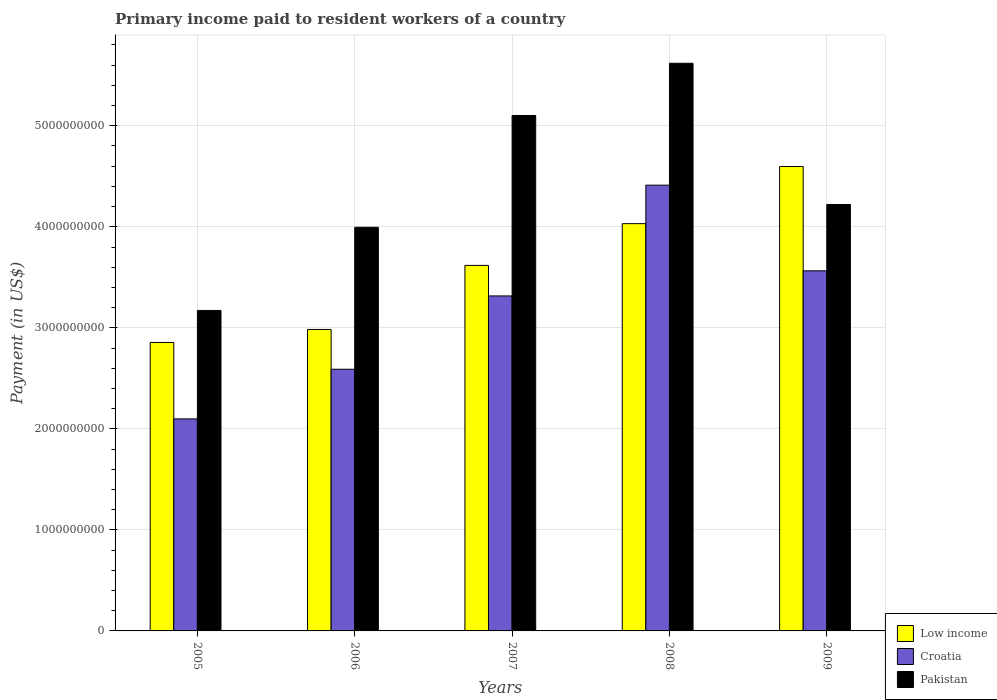How many different coloured bars are there?
Offer a terse response. 3. How many groups of bars are there?
Your response must be concise. 5. Are the number of bars on each tick of the X-axis equal?
Offer a very short reply. Yes. How many bars are there on the 5th tick from the right?
Provide a short and direct response. 3. What is the label of the 5th group of bars from the left?
Give a very brief answer. 2009. In how many cases, is the number of bars for a given year not equal to the number of legend labels?
Your answer should be compact. 0. What is the amount paid to workers in Pakistan in 2009?
Provide a succinct answer. 4.22e+09. Across all years, what is the maximum amount paid to workers in Low income?
Offer a very short reply. 4.60e+09. Across all years, what is the minimum amount paid to workers in Croatia?
Give a very brief answer. 2.10e+09. In which year was the amount paid to workers in Pakistan maximum?
Offer a very short reply. 2008. What is the total amount paid to workers in Pakistan in the graph?
Keep it short and to the point. 2.21e+1. What is the difference between the amount paid to workers in Croatia in 2006 and that in 2008?
Make the answer very short. -1.82e+09. What is the difference between the amount paid to workers in Low income in 2008 and the amount paid to workers in Croatia in 2007?
Keep it short and to the point. 7.16e+08. What is the average amount paid to workers in Croatia per year?
Your answer should be compact. 3.20e+09. In the year 2009, what is the difference between the amount paid to workers in Croatia and amount paid to workers in Pakistan?
Ensure brevity in your answer.  -6.57e+08. In how many years, is the amount paid to workers in Croatia greater than 3000000000 US$?
Ensure brevity in your answer.  3. What is the ratio of the amount paid to workers in Low income in 2005 to that in 2006?
Provide a short and direct response. 0.96. What is the difference between the highest and the second highest amount paid to workers in Pakistan?
Make the answer very short. 5.17e+08. What is the difference between the highest and the lowest amount paid to workers in Pakistan?
Your answer should be very brief. 2.45e+09. In how many years, is the amount paid to workers in Low income greater than the average amount paid to workers in Low income taken over all years?
Ensure brevity in your answer.  3. Is the sum of the amount paid to workers in Pakistan in 2006 and 2009 greater than the maximum amount paid to workers in Low income across all years?
Offer a terse response. Yes. What does the 2nd bar from the right in 2006 represents?
Provide a succinct answer. Croatia. How many years are there in the graph?
Your response must be concise. 5. Are the values on the major ticks of Y-axis written in scientific E-notation?
Give a very brief answer. No. Does the graph contain any zero values?
Your response must be concise. No. Does the graph contain grids?
Keep it short and to the point. Yes. How many legend labels are there?
Provide a succinct answer. 3. What is the title of the graph?
Ensure brevity in your answer.  Primary income paid to resident workers of a country. Does "Guam" appear as one of the legend labels in the graph?
Provide a short and direct response. No. What is the label or title of the X-axis?
Ensure brevity in your answer.  Years. What is the label or title of the Y-axis?
Offer a terse response. Payment (in US$). What is the Payment (in US$) of Low income in 2005?
Your response must be concise. 2.86e+09. What is the Payment (in US$) in Croatia in 2005?
Provide a succinct answer. 2.10e+09. What is the Payment (in US$) of Pakistan in 2005?
Your answer should be compact. 3.17e+09. What is the Payment (in US$) of Low income in 2006?
Offer a terse response. 2.98e+09. What is the Payment (in US$) in Croatia in 2006?
Your answer should be very brief. 2.59e+09. What is the Payment (in US$) in Pakistan in 2006?
Your answer should be very brief. 4.00e+09. What is the Payment (in US$) of Low income in 2007?
Ensure brevity in your answer.  3.62e+09. What is the Payment (in US$) of Croatia in 2007?
Your response must be concise. 3.32e+09. What is the Payment (in US$) of Pakistan in 2007?
Offer a very short reply. 5.10e+09. What is the Payment (in US$) in Low income in 2008?
Your answer should be compact. 4.03e+09. What is the Payment (in US$) in Croatia in 2008?
Provide a short and direct response. 4.41e+09. What is the Payment (in US$) of Pakistan in 2008?
Keep it short and to the point. 5.62e+09. What is the Payment (in US$) of Low income in 2009?
Your answer should be very brief. 4.60e+09. What is the Payment (in US$) in Croatia in 2009?
Provide a short and direct response. 3.56e+09. What is the Payment (in US$) of Pakistan in 2009?
Ensure brevity in your answer.  4.22e+09. Across all years, what is the maximum Payment (in US$) of Low income?
Keep it short and to the point. 4.60e+09. Across all years, what is the maximum Payment (in US$) of Croatia?
Offer a terse response. 4.41e+09. Across all years, what is the maximum Payment (in US$) of Pakistan?
Provide a short and direct response. 5.62e+09. Across all years, what is the minimum Payment (in US$) of Low income?
Provide a succinct answer. 2.86e+09. Across all years, what is the minimum Payment (in US$) of Croatia?
Give a very brief answer. 2.10e+09. Across all years, what is the minimum Payment (in US$) in Pakistan?
Provide a short and direct response. 3.17e+09. What is the total Payment (in US$) of Low income in the graph?
Your response must be concise. 1.81e+1. What is the total Payment (in US$) of Croatia in the graph?
Offer a very short reply. 1.60e+1. What is the total Payment (in US$) in Pakistan in the graph?
Your response must be concise. 2.21e+1. What is the difference between the Payment (in US$) of Low income in 2005 and that in 2006?
Your answer should be very brief. -1.29e+08. What is the difference between the Payment (in US$) in Croatia in 2005 and that in 2006?
Provide a short and direct response. -4.92e+08. What is the difference between the Payment (in US$) in Pakistan in 2005 and that in 2006?
Offer a terse response. -8.23e+08. What is the difference between the Payment (in US$) in Low income in 2005 and that in 2007?
Your answer should be compact. -7.63e+08. What is the difference between the Payment (in US$) of Croatia in 2005 and that in 2007?
Make the answer very short. -1.22e+09. What is the difference between the Payment (in US$) in Pakistan in 2005 and that in 2007?
Your answer should be very brief. -1.93e+09. What is the difference between the Payment (in US$) of Low income in 2005 and that in 2008?
Make the answer very short. -1.18e+09. What is the difference between the Payment (in US$) of Croatia in 2005 and that in 2008?
Your answer should be compact. -2.31e+09. What is the difference between the Payment (in US$) in Pakistan in 2005 and that in 2008?
Provide a short and direct response. -2.45e+09. What is the difference between the Payment (in US$) in Low income in 2005 and that in 2009?
Offer a very short reply. -1.74e+09. What is the difference between the Payment (in US$) in Croatia in 2005 and that in 2009?
Make the answer very short. -1.47e+09. What is the difference between the Payment (in US$) in Pakistan in 2005 and that in 2009?
Give a very brief answer. -1.05e+09. What is the difference between the Payment (in US$) in Low income in 2006 and that in 2007?
Provide a succinct answer. -6.34e+08. What is the difference between the Payment (in US$) in Croatia in 2006 and that in 2007?
Offer a very short reply. -7.26e+08. What is the difference between the Payment (in US$) in Pakistan in 2006 and that in 2007?
Provide a short and direct response. -1.11e+09. What is the difference between the Payment (in US$) in Low income in 2006 and that in 2008?
Your answer should be very brief. -1.05e+09. What is the difference between the Payment (in US$) of Croatia in 2006 and that in 2008?
Your response must be concise. -1.82e+09. What is the difference between the Payment (in US$) in Pakistan in 2006 and that in 2008?
Provide a short and direct response. -1.62e+09. What is the difference between the Payment (in US$) of Low income in 2006 and that in 2009?
Provide a succinct answer. -1.61e+09. What is the difference between the Payment (in US$) in Croatia in 2006 and that in 2009?
Offer a very short reply. -9.74e+08. What is the difference between the Payment (in US$) in Pakistan in 2006 and that in 2009?
Give a very brief answer. -2.26e+08. What is the difference between the Payment (in US$) of Low income in 2007 and that in 2008?
Keep it short and to the point. -4.13e+08. What is the difference between the Payment (in US$) of Croatia in 2007 and that in 2008?
Your response must be concise. -1.10e+09. What is the difference between the Payment (in US$) in Pakistan in 2007 and that in 2008?
Your answer should be very brief. -5.17e+08. What is the difference between the Payment (in US$) of Low income in 2007 and that in 2009?
Provide a short and direct response. -9.79e+08. What is the difference between the Payment (in US$) of Croatia in 2007 and that in 2009?
Keep it short and to the point. -2.48e+08. What is the difference between the Payment (in US$) in Pakistan in 2007 and that in 2009?
Offer a terse response. 8.81e+08. What is the difference between the Payment (in US$) of Low income in 2008 and that in 2009?
Your answer should be compact. -5.66e+08. What is the difference between the Payment (in US$) in Croatia in 2008 and that in 2009?
Make the answer very short. 8.48e+08. What is the difference between the Payment (in US$) in Pakistan in 2008 and that in 2009?
Offer a very short reply. 1.40e+09. What is the difference between the Payment (in US$) in Low income in 2005 and the Payment (in US$) in Croatia in 2006?
Your response must be concise. 2.65e+08. What is the difference between the Payment (in US$) in Low income in 2005 and the Payment (in US$) in Pakistan in 2006?
Offer a very short reply. -1.14e+09. What is the difference between the Payment (in US$) in Croatia in 2005 and the Payment (in US$) in Pakistan in 2006?
Your answer should be very brief. -1.90e+09. What is the difference between the Payment (in US$) in Low income in 2005 and the Payment (in US$) in Croatia in 2007?
Your response must be concise. -4.61e+08. What is the difference between the Payment (in US$) in Low income in 2005 and the Payment (in US$) in Pakistan in 2007?
Provide a succinct answer. -2.25e+09. What is the difference between the Payment (in US$) in Croatia in 2005 and the Payment (in US$) in Pakistan in 2007?
Keep it short and to the point. -3.00e+09. What is the difference between the Payment (in US$) of Low income in 2005 and the Payment (in US$) of Croatia in 2008?
Keep it short and to the point. -1.56e+09. What is the difference between the Payment (in US$) in Low income in 2005 and the Payment (in US$) in Pakistan in 2008?
Provide a succinct answer. -2.76e+09. What is the difference between the Payment (in US$) of Croatia in 2005 and the Payment (in US$) of Pakistan in 2008?
Offer a very short reply. -3.52e+09. What is the difference between the Payment (in US$) of Low income in 2005 and the Payment (in US$) of Croatia in 2009?
Offer a very short reply. -7.09e+08. What is the difference between the Payment (in US$) in Low income in 2005 and the Payment (in US$) in Pakistan in 2009?
Give a very brief answer. -1.37e+09. What is the difference between the Payment (in US$) in Croatia in 2005 and the Payment (in US$) in Pakistan in 2009?
Provide a succinct answer. -2.12e+09. What is the difference between the Payment (in US$) of Low income in 2006 and the Payment (in US$) of Croatia in 2007?
Give a very brief answer. -3.32e+08. What is the difference between the Payment (in US$) in Low income in 2006 and the Payment (in US$) in Pakistan in 2007?
Keep it short and to the point. -2.12e+09. What is the difference between the Payment (in US$) of Croatia in 2006 and the Payment (in US$) of Pakistan in 2007?
Offer a terse response. -2.51e+09. What is the difference between the Payment (in US$) of Low income in 2006 and the Payment (in US$) of Croatia in 2008?
Ensure brevity in your answer.  -1.43e+09. What is the difference between the Payment (in US$) in Low income in 2006 and the Payment (in US$) in Pakistan in 2008?
Provide a short and direct response. -2.63e+09. What is the difference between the Payment (in US$) of Croatia in 2006 and the Payment (in US$) of Pakistan in 2008?
Your answer should be very brief. -3.03e+09. What is the difference between the Payment (in US$) in Low income in 2006 and the Payment (in US$) in Croatia in 2009?
Give a very brief answer. -5.80e+08. What is the difference between the Payment (in US$) of Low income in 2006 and the Payment (in US$) of Pakistan in 2009?
Your answer should be very brief. -1.24e+09. What is the difference between the Payment (in US$) of Croatia in 2006 and the Payment (in US$) of Pakistan in 2009?
Offer a very short reply. -1.63e+09. What is the difference between the Payment (in US$) in Low income in 2007 and the Payment (in US$) in Croatia in 2008?
Offer a terse response. -7.94e+08. What is the difference between the Payment (in US$) of Low income in 2007 and the Payment (in US$) of Pakistan in 2008?
Give a very brief answer. -2.00e+09. What is the difference between the Payment (in US$) in Croatia in 2007 and the Payment (in US$) in Pakistan in 2008?
Offer a very short reply. -2.30e+09. What is the difference between the Payment (in US$) in Low income in 2007 and the Payment (in US$) in Croatia in 2009?
Keep it short and to the point. 5.39e+07. What is the difference between the Payment (in US$) of Low income in 2007 and the Payment (in US$) of Pakistan in 2009?
Give a very brief answer. -6.03e+08. What is the difference between the Payment (in US$) in Croatia in 2007 and the Payment (in US$) in Pakistan in 2009?
Keep it short and to the point. -9.05e+08. What is the difference between the Payment (in US$) of Low income in 2008 and the Payment (in US$) of Croatia in 2009?
Provide a short and direct response. 4.67e+08. What is the difference between the Payment (in US$) in Low income in 2008 and the Payment (in US$) in Pakistan in 2009?
Provide a succinct answer. -1.90e+08. What is the difference between the Payment (in US$) of Croatia in 2008 and the Payment (in US$) of Pakistan in 2009?
Your answer should be compact. 1.91e+08. What is the average Payment (in US$) of Low income per year?
Your response must be concise. 3.62e+09. What is the average Payment (in US$) in Croatia per year?
Your answer should be very brief. 3.20e+09. What is the average Payment (in US$) in Pakistan per year?
Make the answer very short. 4.42e+09. In the year 2005, what is the difference between the Payment (in US$) in Low income and Payment (in US$) in Croatia?
Ensure brevity in your answer.  7.57e+08. In the year 2005, what is the difference between the Payment (in US$) in Low income and Payment (in US$) in Pakistan?
Your answer should be very brief. -3.17e+08. In the year 2005, what is the difference between the Payment (in US$) in Croatia and Payment (in US$) in Pakistan?
Provide a short and direct response. -1.07e+09. In the year 2006, what is the difference between the Payment (in US$) of Low income and Payment (in US$) of Croatia?
Offer a very short reply. 3.94e+08. In the year 2006, what is the difference between the Payment (in US$) in Low income and Payment (in US$) in Pakistan?
Provide a succinct answer. -1.01e+09. In the year 2006, what is the difference between the Payment (in US$) of Croatia and Payment (in US$) of Pakistan?
Your answer should be compact. -1.41e+09. In the year 2007, what is the difference between the Payment (in US$) of Low income and Payment (in US$) of Croatia?
Give a very brief answer. 3.02e+08. In the year 2007, what is the difference between the Payment (in US$) in Low income and Payment (in US$) in Pakistan?
Make the answer very short. -1.48e+09. In the year 2007, what is the difference between the Payment (in US$) in Croatia and Payment (in US$) in Pakistan?
Offer a very short reply. -1.79e+09. In the year 2008, what is the difference between the Payment (in US$) of Low income and Payment (in US$) of Croatia?
Offer a terse response. -3.81e+08. In the year 2008, what is the difference between the Payment (in US$) of Low income and Payment (in US$) of Pakistan?
Your response must be concise. -1.59e+09. In the year 2008, what is the difference between the Payment (in US$) in Croatia and Payment (in US$) in Pakistan?
Keep it short and to the point. -1.21e+09. In the year 2009, what is the difference between the Payment (in US$) in Low income and Payment (in US$) in Croatia?
Provide a short and direct response. 1.03e+09. In the year 2009, what is the difference between the Payment (in US$) in Low income and Payment (in US$) in Pakistan?
Provide a succinct answer. 3.76e+08. In the year 2009, what is the difference between the Payment (in US$) of Croatia and Payment (in US$) of Pakistan?
Your response must be concise. -6.57e+08. What is the ratio of the Payment (in US$) of Low income in 2005 to that in 2006?
Provide a succinct answer. 0.96. What is the ratio of the Payment (in US$) in Croatia in 2005 to that in 2006?
Provide a succinct answer. 0.81. What is the ratio of the Payment (in US$) of Pakistan in 2005 to that in 2006?
Provide a succinct answer. 0.79. What is the ratio of the Payment (in US$) of Low income in 2005 to that in 2007?
Ensure brevity in your answer.  0.79. What is the ratio of the Payment (in US$) in Croatia in 2005 to that in 2007?
Provide a succinct answer. 0.63. What is the ratio of the Payment (in US$) in Pakistan in 2005 to that in 2007?
Provide a short and direct response. 0.62. What is the ratio of the Payment (in US$) in Low income in 2005 to that in 2008?
Provide a succinct answer. 0.71. What is the ratio of the Payment (in US$) in Croatia in 2005 to that in 2008?
Your answer should be very brief. 0.48. What is the ratio of the Payment (in US$) of Pakistan in 2005 to that in 2008?
Your answer should be compact. 0.56. What is the ratio of the Payment (in US$) in Low income in 2005 to that in 2009?
Provide a succinct answer. 0.62. What is the ratio of the Payment (in US$) in Croatia in 2005 to that in 2009?
Your answer should be compact. 0.59. What is the ratio of the Payment (in US$) of Pakistan in 2005 to that in 2009?
Offer a very short reply. 0.75. What is the ratio of the Payment (in US$) of Low income in 2006 to that in 2007?
Keep it short and to the point. 0.82. What is the ratio of the Payment (in US$) in Croatia in 2006 to that in 2007?
Offer a terse response. 0.78. What is the ratio of the Payment (in US$) of Pakistan in 2006 to that in 2007?
Offer a very short reply. 0.78. What is the ratio of the Payment (in US$) in Low income in 2006 to that in 2008?
Make the answer very short. 0.74. What is the ratio of the Payment (in US$) of Croatia in 2006 to that in 2008?
Keep it short and to the point. 0.59. What is the ratio of the Payment (in US$) of Pakistan in 2006 to that in 2008?
Offer a very short reply. 0.71. What is the ratio of the Payment (in US$) of Low income in 2006 to that in 2009?
Your response must be concise. 0.65. What is the ratio of the Payment (in US$) of Croatia in 2006 to that in 2009?
Your answer should be very brief. 0.73. What is the ratio of the Payment (in US$) of Pakistan in 2006 to that in 2009?
Provide a succinct answer. 0.95. What is the ratio of the Payment (in US$) in Low income in 2007 to that in 2008?
Your answer should be compact. 0.9. What is the ratio of the Payment (in US$) of Croatia in 2007 to that in 2008?
Offer a very short reply. 0.75. What is the ratio of the Payment (in US$) of Pakistan in 2007 to that in 2008?
Your answer should be compact. 0.91. What is the ratio of the Payment (in US$) in Low income in 2007 to that in 2009?
Give a very brief answer. 0.79. What is the ratio of the Payment (in US$) of Croatia in 2007 to that in 2009?
Your response must be concise. 0.93. What is the ratio of the Payment (in US$) in Pakistan in 2007 to that in 2009?
Give a very brief answer. 1.21. What is the ratio of the Payment (in US$) of Low income in 2008 to that in 2009?
Ensure brevity in your answer.  0.88. What is the ratio of the Payment (in US$) in Croatia in 2008 to that in 2009?
Your answer should be very brief. 1.24. What is the ratio of the Payment (in US$) in Pakistan in 2008 to that in 2009?
Keep it short and to the point. 1.33. What is the difference between the highest and the second highest Payment (in US$) of Low income?
Provide a short and direct response. 5.66e+08. What is the difference between the highest and the second highest Payment (in US$) in Croatia?
Ensure brevity in your answer.  8.48e+08. What is the difference between the highest and the second highest Payment (in US$) of Pakistan?
Ensure brevity in your answer.  5.17e+08. What is the difference between the highest and the lowest Payment (in US$) in Low income?
Offer a terse response. 1.74e+09. What is the difference between the highest and the lowest Payment (in US$) in Croatia?
Your answer should be very brief. 2.31e+09. What is the difference between the highest and the lowest Payment (in US$) in Pakistan?
Give a very brief answer. 2.45e+09. 